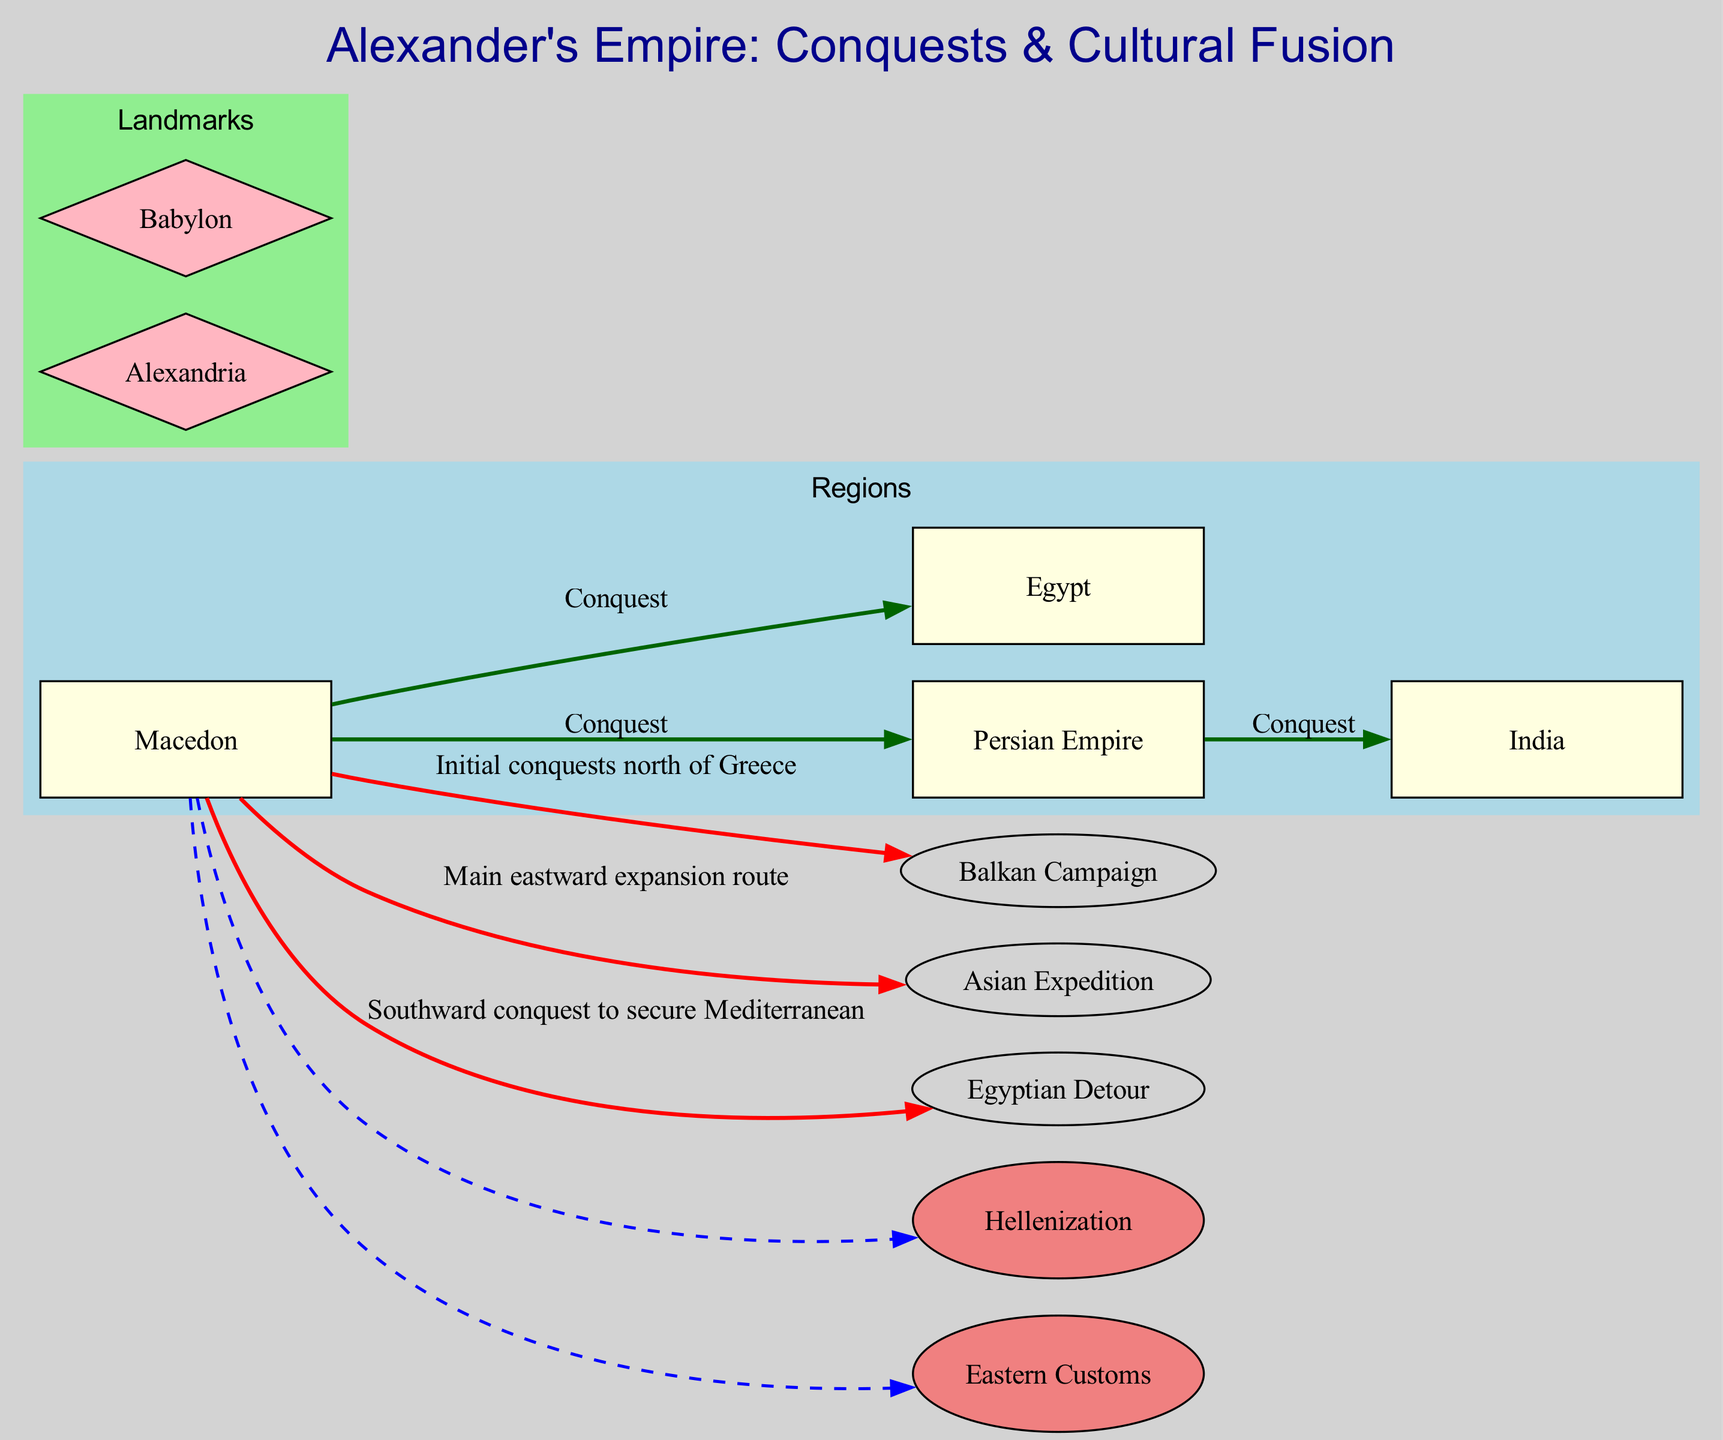What is the starting point of Alexander's conquests? The diagram identifies Macedon as the starting point, highlighting it and indicating its significance in Alexander's campaigns.
Answer: Macedon How many regions are highlighted in the diagram? There are four regions labeled on the diagram: Macedon, Persian Empire, Egypt, and India. Counting these gives a total of four regions.
Answer: 4 What color represents the routes in the diagram? Upon inspecting the diagram, routes are shown as red edges connecting various nodes, indicating the paths of conquest taken by Alexander.
Answer: Red What major city did Alexander found in Egypt? The diagram indicates Alexandria as a major landmark, specifically denoting it as a significant city established during his conquests in Egypt.
Answer: Alexandria Which cultural influence represents the spread of Greek culture? The diagram highlights Hellenization as a cultural influence, showing its connection to Macedon through a dashed line, indicating the cultural spread post-conquest.
Answer: Hellenization What was the main target of Alexander’s conquests? The diagram shows the Persian Empire connected directly to Macedon, denoting it as the primary region where the conquests took place.
Answer: Persian Empire How does the Egyptian Detour route connect to regional conquests? The Egyptian Detour route is shown as a red edge originating from Macedon, leading down to Egypt, indicating a southward conquest to secure that area.
Answer: Southward Which two landmarks are shown in the diagram? The diagram details two landmarks: Alexandria in Egypt and Babylon, which is marked as the capital of Alexander's empire.
Answer: Alexandria, Babylon Which cultural influence represents the adoption of Persian customs? Eastern Customs is specified in the diagram as a cultural influence that reflects the integration of some Persian practices within Alexander's empire.
Answer: Eastern Customs 